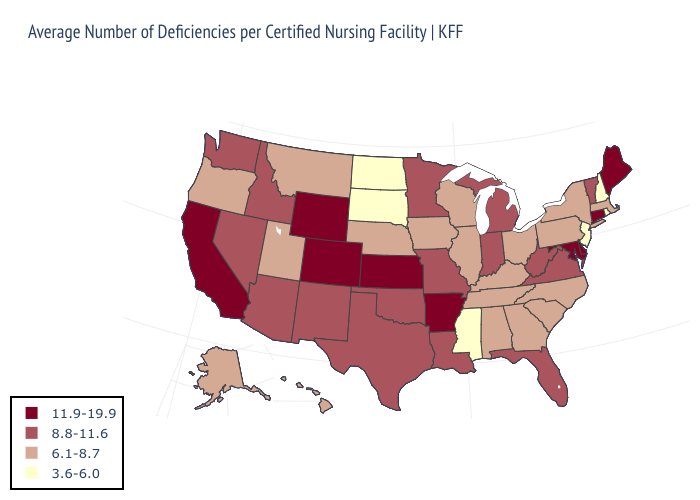What is the lowest value in states that border Texas?
Keep it brief. 8.8-11.6. How many symbols are there in the legend?
Give a very brief answer. 4. Does Arizona have the lowest value in the West?
Give a very brief answer. No. Does the first symbol in the legend represent the smallest category?
Give a very brief answer. No. What is the lowest value in the MidWest?
Write a very short answer. 3.6-6.0. Does Oregon have the lowest value in the West?
Give a very brief answer. Yes. How many symbols are there in the legend?
Be succinct. 4. Does Colorado have the highest value in the USA?
Concise answer only. Yes. Does Colorado have the same value as California?
Be succinct. Yes. What is the lowest value in the West?
Short answer required. 6.1-8.7. Does the map have missing data?
Short answer required. No. Name the states that have a value in the range 6.1-8.7?
Short answer required. Alabama, Alaska, Georgia, Hawaii, Illinois, Iowa, Kentucky, Massachusetts, Montana, Nebraska, New York, North Carolina, Ohio, Oregon, Pennsylvania, South Carolina, Tennessee, Utah, Wisconsin. Name the states that have a value in the range 11.9-19.9?
Concise answer only. Arkansas, California, Colorado, Connecticut, Delaware, Kansas, Maine, Maryland, Wyoming. What is the value of New York?
Give a very brief answer. 6.1-8.7. Which states have the lowest value in the USA?
Be succinct. Mississippi, New Hampshire, New Jersey, North Dakota, Rhode Island, South Dakota. 